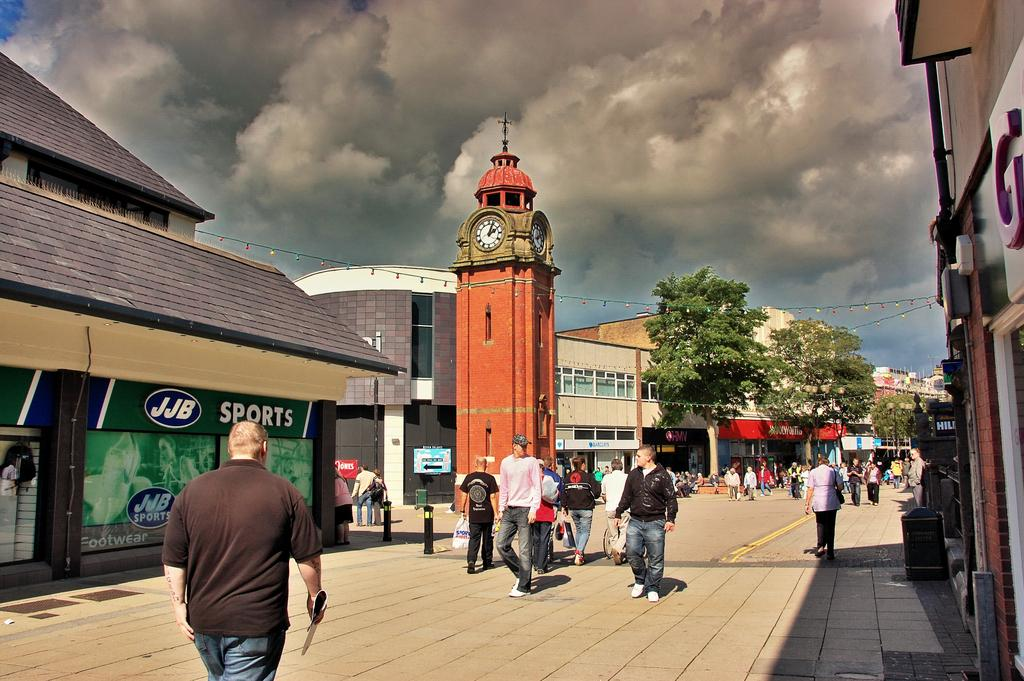What are the people in the image doing? The people in the image are walking on the road. What can be seen in the background of the image? In the background of the image, there are houses, boards, a clock tower, buildings, trees, wires, and the sky. What is the condition of the sky in the image? The sky appears to be cloudy in the image. What scent is being emitted by the cherry tree in the image? There is no cherry tree present in the image, so it is not possible to determine the scent being emitted. 